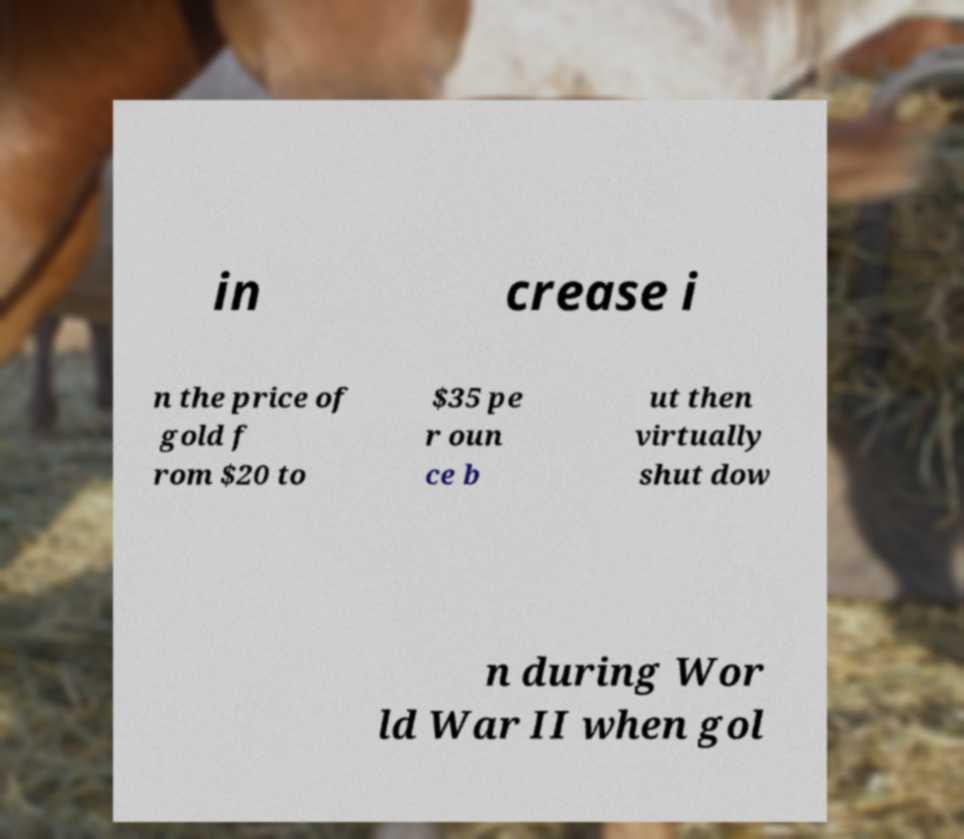Please read and relay the text visible in this image. What does it say? in crease i n the price of gold f rom $20 to $35 pe r oun ce b ut then virtually shut dow n during Wor ld War II when gol 